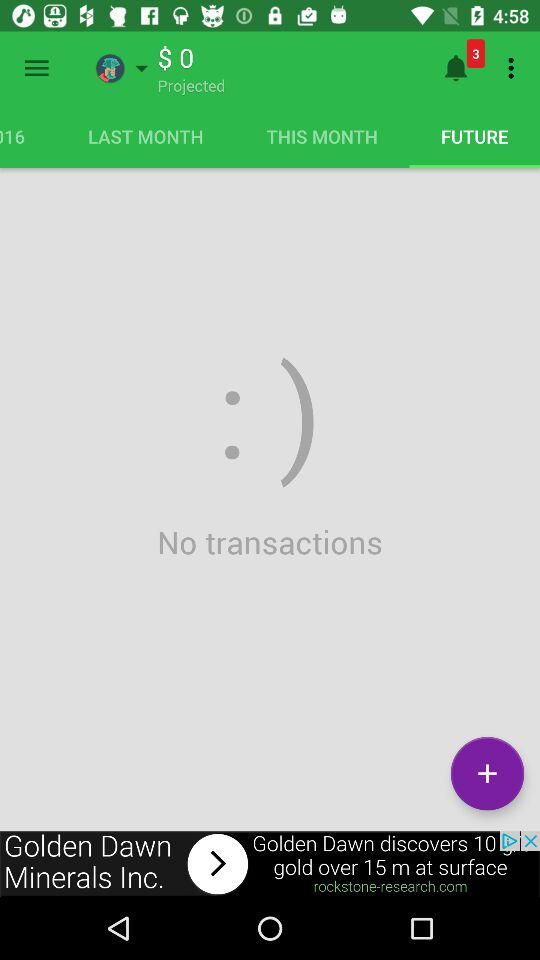How much money is projected to be spent?
Answer the question using a single word or phrase. $0 